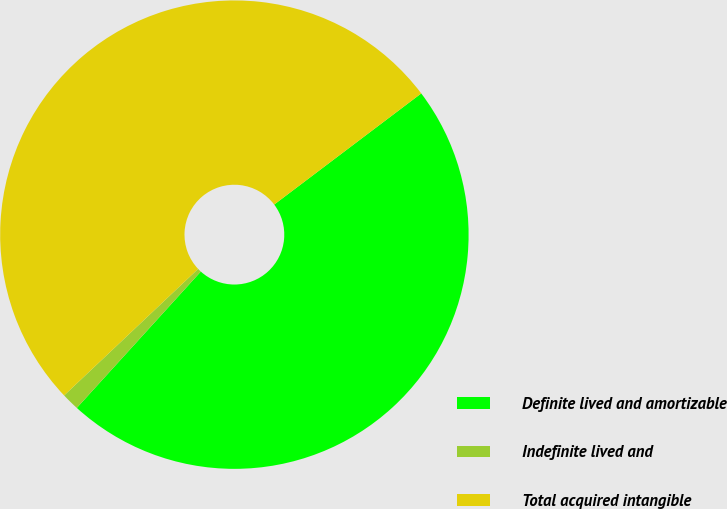Convert chart to OTSL. <chart><loc_0><loc_0><loc_500><loc_500><pie_chart><fcel>Definite lived and amortizable<fcel>Indefinite lived and<fcel>Total acquired intangible<nl><fcel>47.04%<fcel>1.21%<fcel>51.74%<nl></chart> 